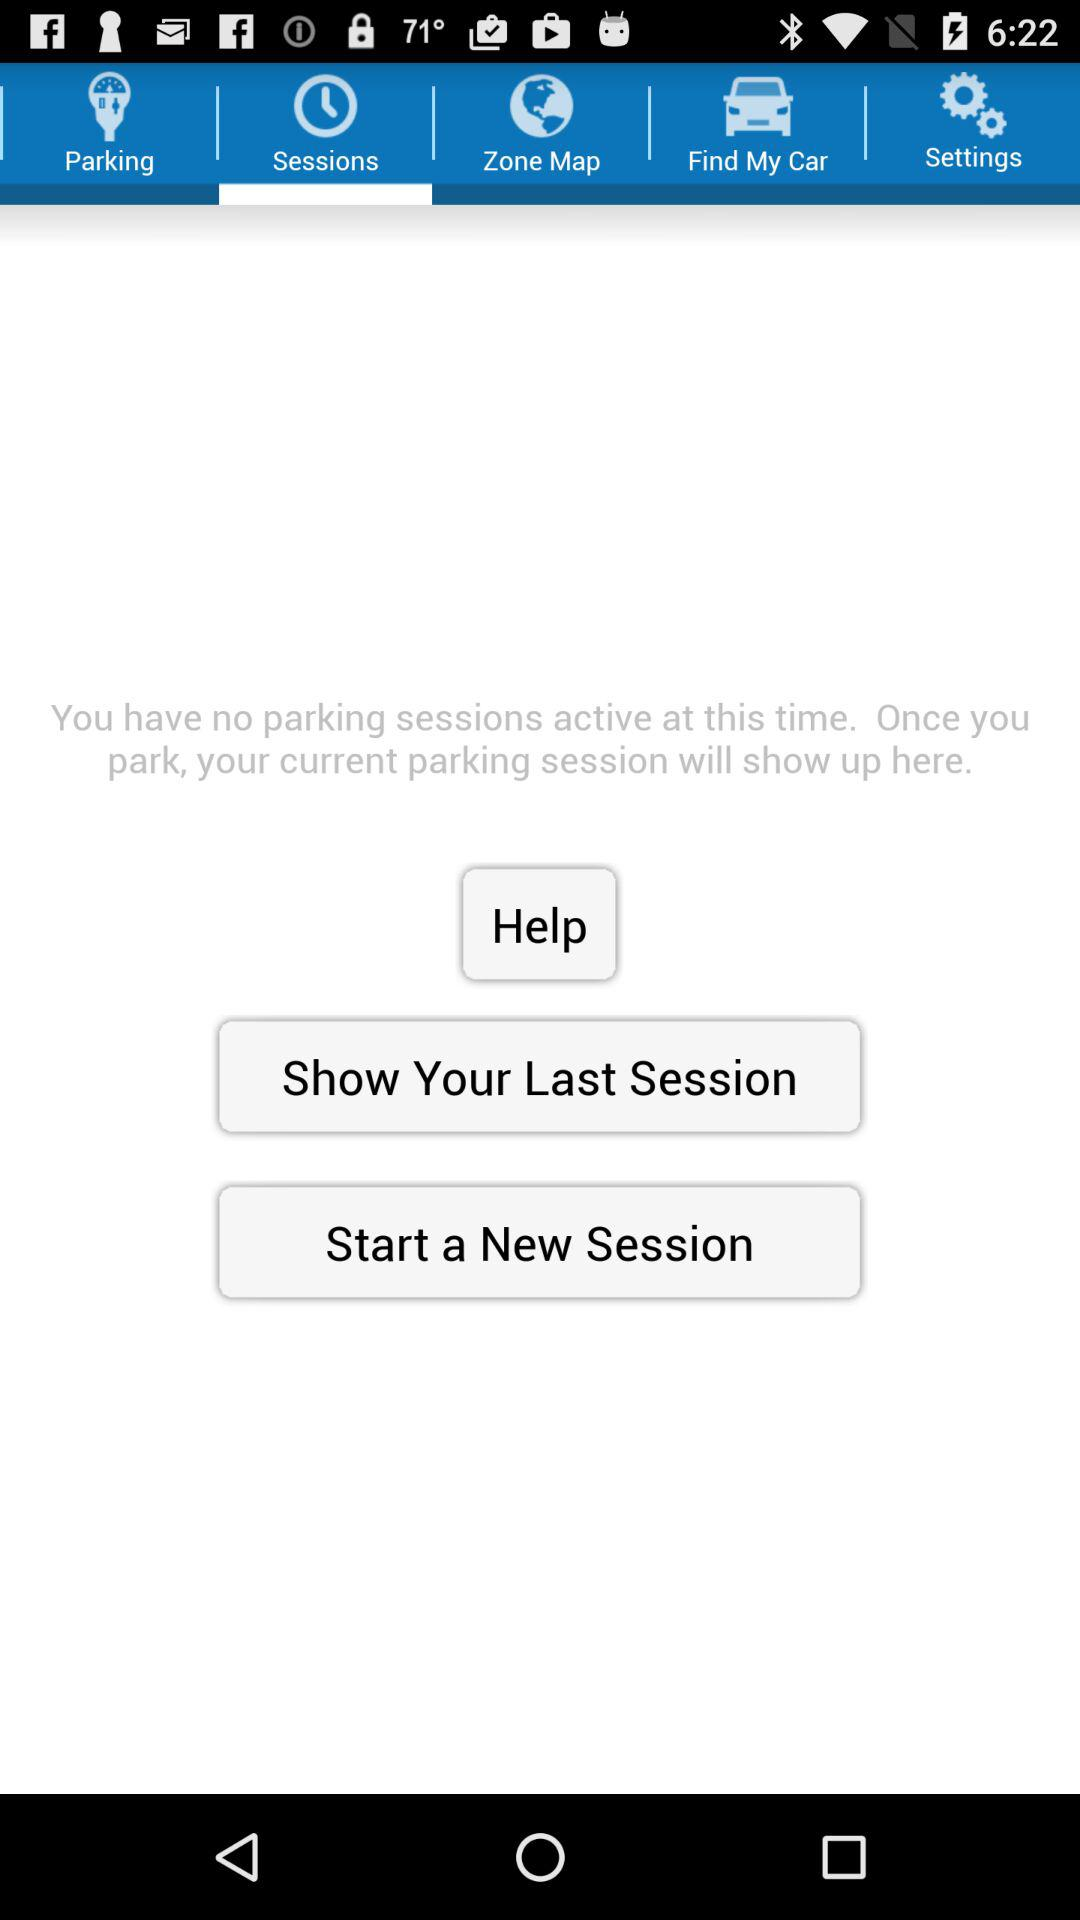How will my parking session show here? Your parking session will show up once you park. 